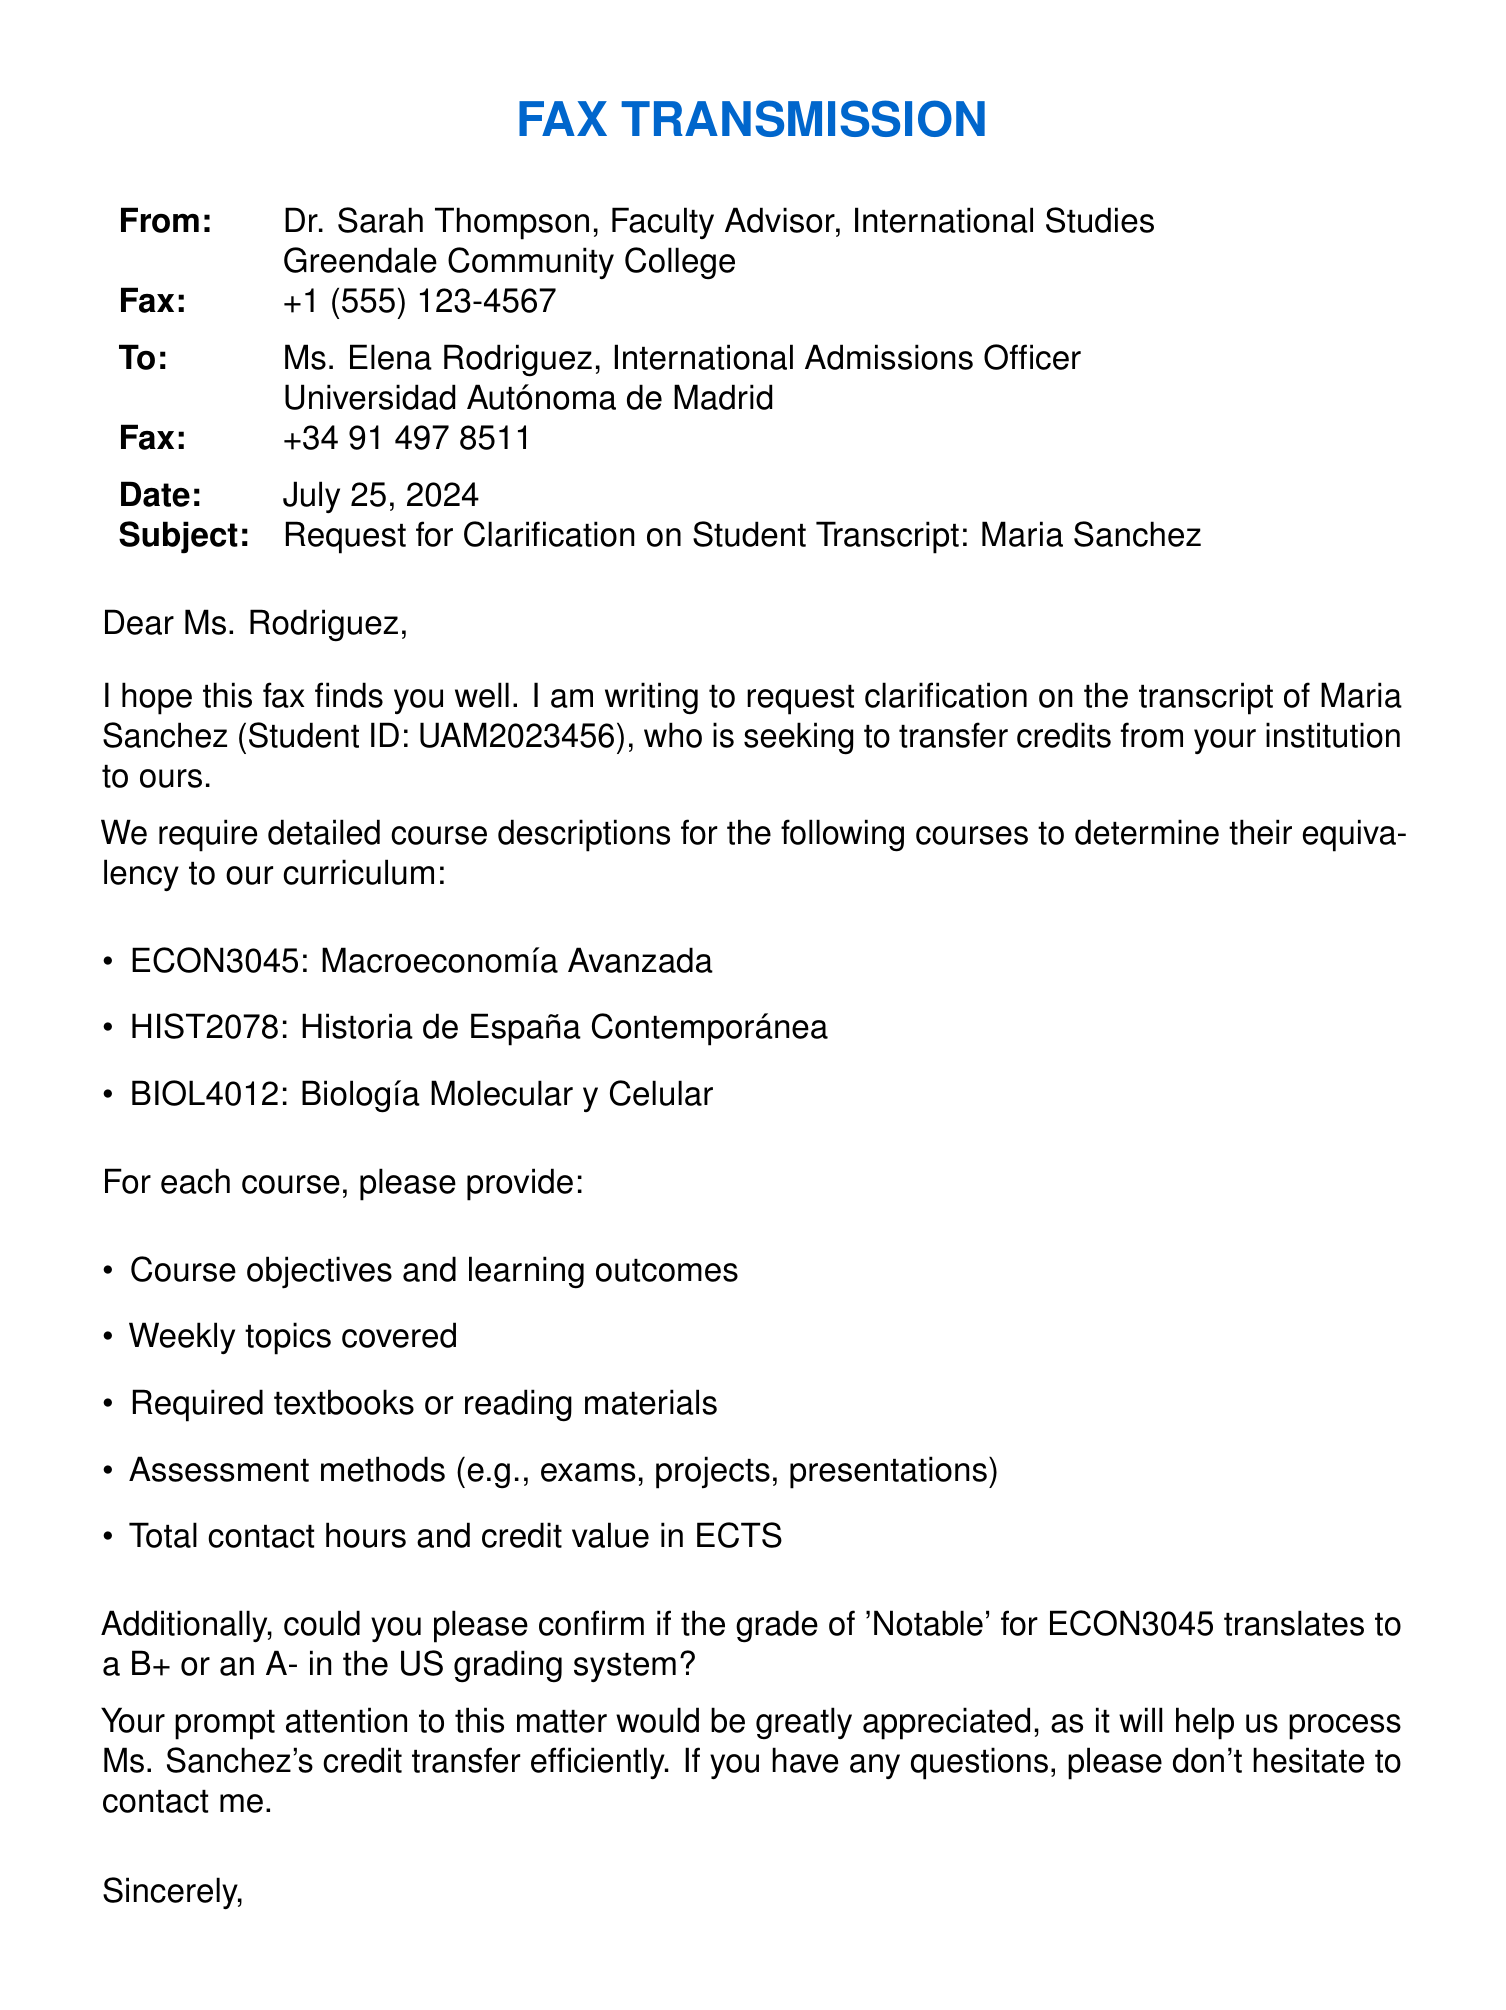What is the name of the student? The fax requests clarification on the transcript of Maria Sanchez, which is mentioned in the subject line.
Answer: Maria Sanchez Who is the sender of the fax? The sender is Dr. Sarah Thompson, as stated at the beginning of the fax.
Answer: Dr. Sarah Thompson What is the course code for Advanced Macroeconomics? The fax lists the course code for Advanced Macroeconomics under the courses requiring clarification.
Answer: ECON3045 What grade does Dr. Thompson want to confirm for ECON3045? The fax specifically asks for confirmation of the grade 'Notable' for ECON3045 and its US equivalent.
Answer: Notable What is the recipient's fax number? The fax number for Ms. Elena Rodriguez is provided in the contact details section.
Answer: +34 91 497 8511 What information is requested for each course? The fax requests course objectives, weekly topics, textbooks, assessment methods, total contact hours, and credit value in ECTS.
Answer: Course objectives and learning outcomes, weekly topics covered, required textbooks or reading materials, assessment methods, total contact hours and credit value in ECTS On what date was the fax sent? The date on the fax is specified in the document as "today," which takes the current date when sent.
Answer: Today's date What is the purpose of the fax? The fax is sent to request clarification on a student's international transcript to facilitate credit transfers.
Answer: Request for clarification on student transcript 